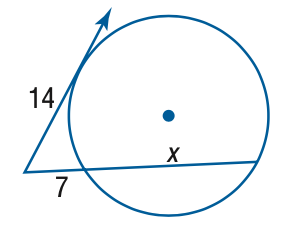Answer the mathemtical geometry problem and directly provide the correct option letter.
Question: Find x. Assume that segments that appear to be tangent are tangent.
Choices: A: 14 B: 21 C: 28 D: 35 B 